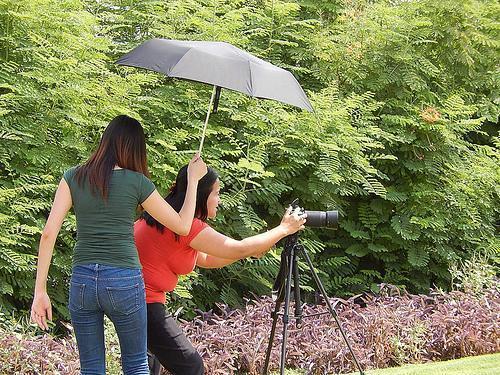How many people are shown?
Give a very brief answer. 2. 